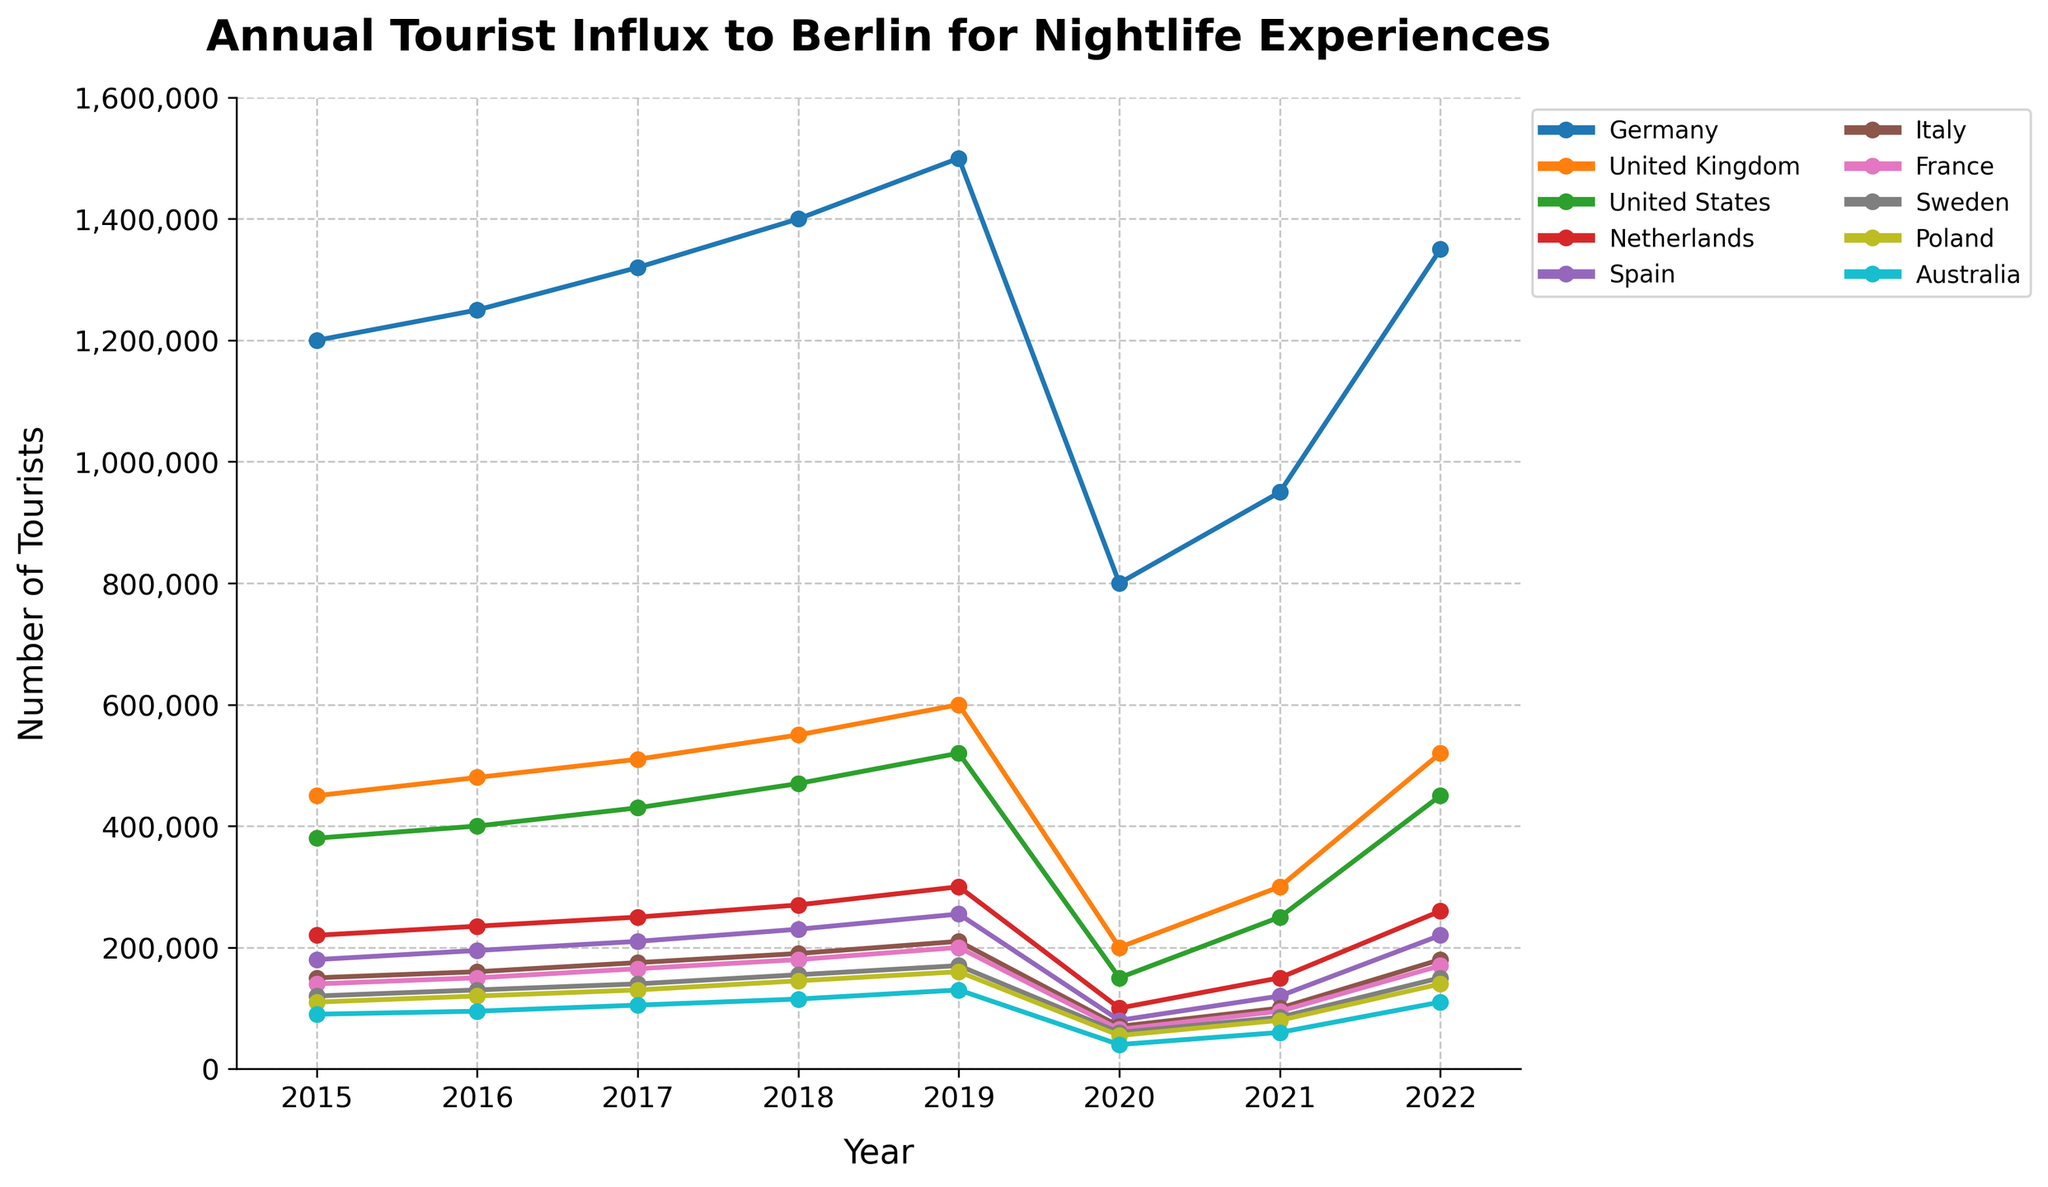Which country had the highest number of tourists visiting Berlin for nightlife experiences in 2019? The figure shows the tourist influx numbers for each country. In 2019, Germany has the highest number of tourists with 1,500,000.
Answer: Germany Which country had the lowest number of tourists visiting Berlin for nightlife experiences in 2020? The figure shows the tourist influx numbers for each country. In 2020, Australia has the lowest number of tourists with 40,000.
Answer: Australia By how much did the tourist influx from Spain decrease from 2019 to 2020? To calculate the decrease, we subtract the number in 2020 from the number in 2019: 255,000 - 80,000 = 175,000.
Answer: 175,000 What is the total tourist influx from the United States and the United Kingdom in 2021? Adding the tourist numbers for the United States (250,000) and the United Kingdom (300,000) gives us: 250,000 + 300,000 = 550,000.
Answer: 550,000 Which year saw the highest increase in tourist influx from Germany compared to the previous year? Calculate the difference in tourist numbers for each consecutive year and identify the largest increase: 
2016-2015: 125,000, 
2017-2016: 70,000, 
2018-2017: 80,000, 
2019-2018: 100,000, 
2020-2019: -700,000,
2021-2020: 150,000, 
2022-2021: 400,000.
The highest increase is from 2021 to 2022, with an increase of 400,000.
Answer: 2021 to 2022 Despite the drop in 2020, which country still managed to attract more than 100,000 tourists to Berlin for nightlife in 2021? Checking the 2021 values, Germany (950,000), United Kingdom (300,000), United States (250,000), Netherlands (150,000), Spain (120,000), and France (95,000) have more than 100,000. Therefore, Germany, United Kingdom, United States, Netherlands, and Spain managed to attract more than 100,000 tourists in 2021.
Answer: Germany, United Kingdom, United States, Netherlands, Spain In which year did Sweden see its highest number of tourists visiting Berlin for nightlife experiences? The figure shows the tourist influx numbers for each country by year. Sweden had its highest number in 2019 with 170,000 tourists.
Answer: 2019 From 2015 to 2019, how much did the tourist influx from Italy increase? To find the increase, we subtract the 2015 number from the 2019 number: 210,000 - 150,000 = 60,000.
Answer: 60,000 Which year showed the largest drop in the number of tourists from Australia, and what was the drop? Comparing each year, the largest drop was from 2019 to 2020: 130,000 - 40,000 = 90,000.
Answer: 2019 to 2020, 90,000 